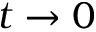<formula> <loc_0><loc_0><loc_500><loc_500>t \to 0</formula> 